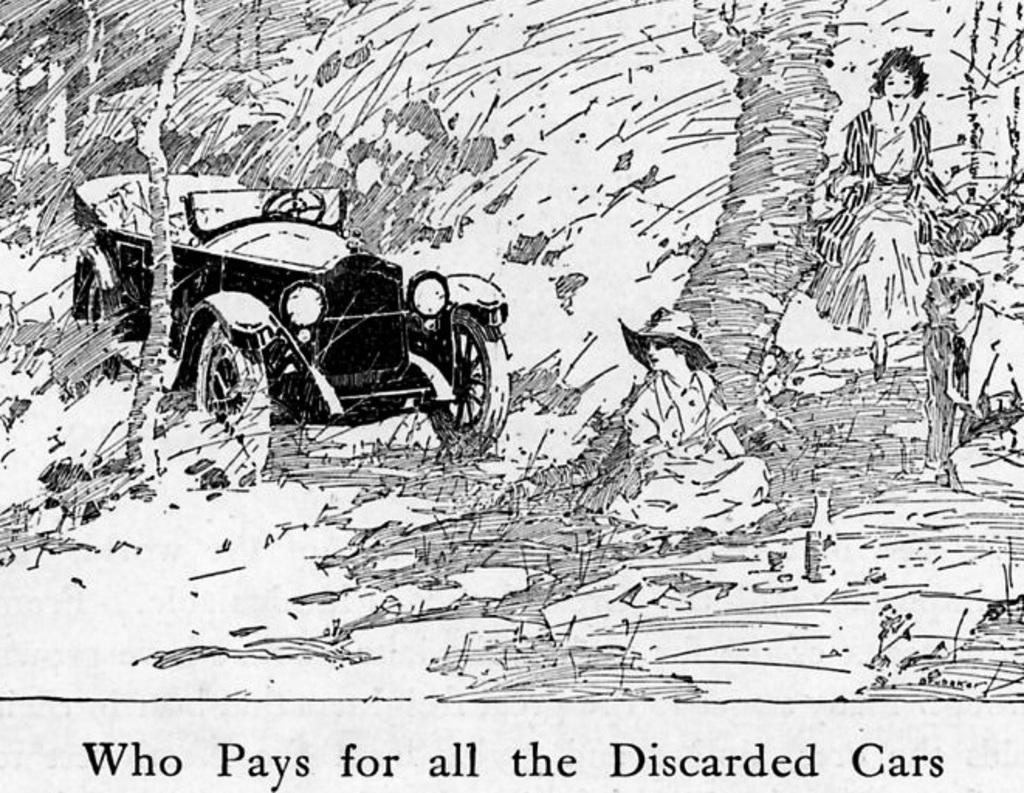Please provide a concise description of this image. It is a sketch in the left side a jeep is there. In the middle a person is sitting, in the right side a girl is walking. 